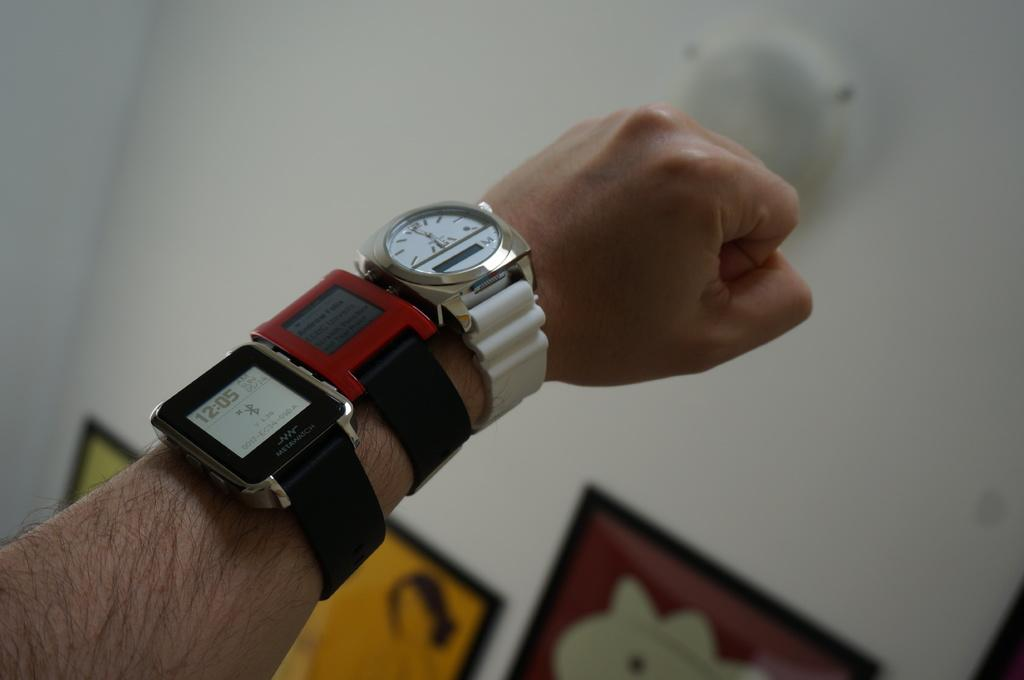<image>
Give a short and clear explanation of the subsequent image. A man wearing a watch that shows 12:05 as the time. 